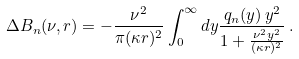<formula> <loc_0><loc_0><loc_500><loc_500>\Delta B _ { n } ( \nu , r ) = - \frac { \nu ^ { 2 } } { \pi ( \kappa r ) ^ { 2 } } \int _ { 0 } ^ { \infty } d y \frac { q _ { n } ( y ) \, y ^ { 2 } } { 1 + \frac { \nu ^ { 2 } y ^ { 2 } } { ( \kappa r ) ^ { 2 } } } \, .</formula> 